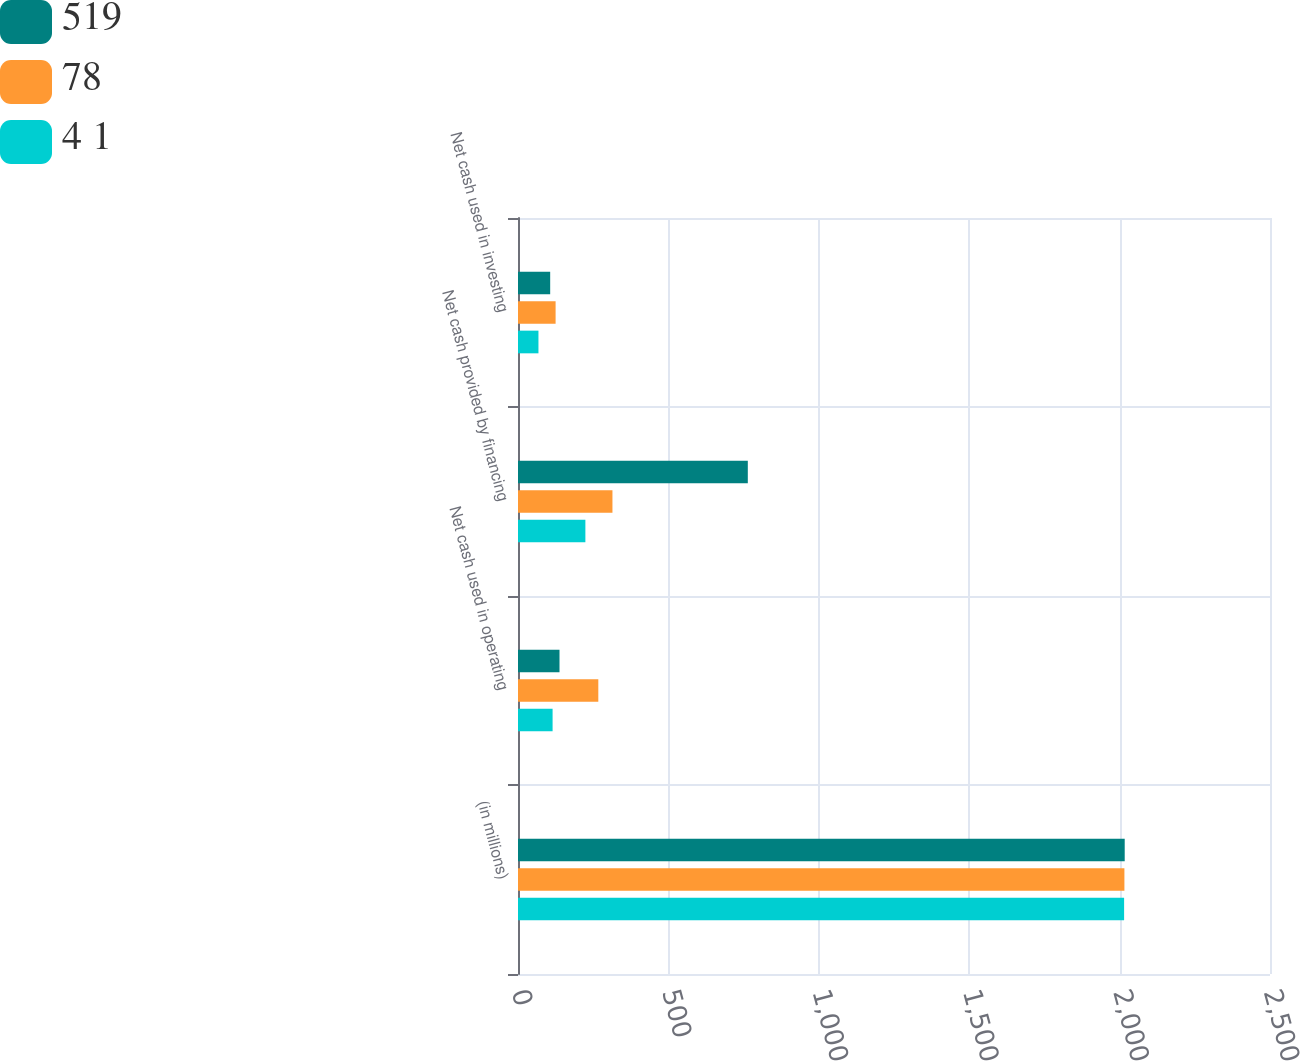Convert chart to OTSL. <chart><loc_0><loc_0><loc_500><loc_500><stacked_bar_chart><ecel><fcel>(in millions)<fcel>Net cash used in operating<fcel>Net cash provided by financing<fcel>Net cash used in investing<nl><fcel>519<fcel>2017<fcel>138<fcel>764<fcel>107<nl><fcel>78<fcel>2016<fcel>267<fcel>314<fcel>125<nl><fcel>4 1<fcel>2015<fcel>115<fcel>224<fcel>68<nl></chart> 